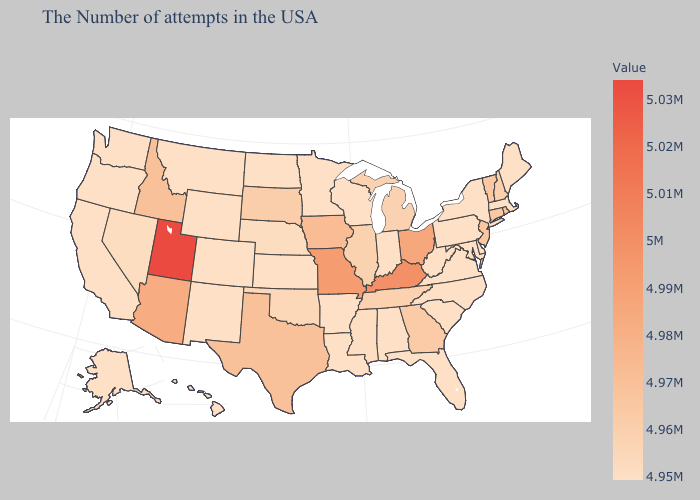Among the states that border Maine , which have the highest value?
Keep it brief. New Hampshire. Does Tennessee have the lowest value in the South?
Answer briefly. No. Does Utah have the highest value in the USA?
Quick response, please. Yes. 